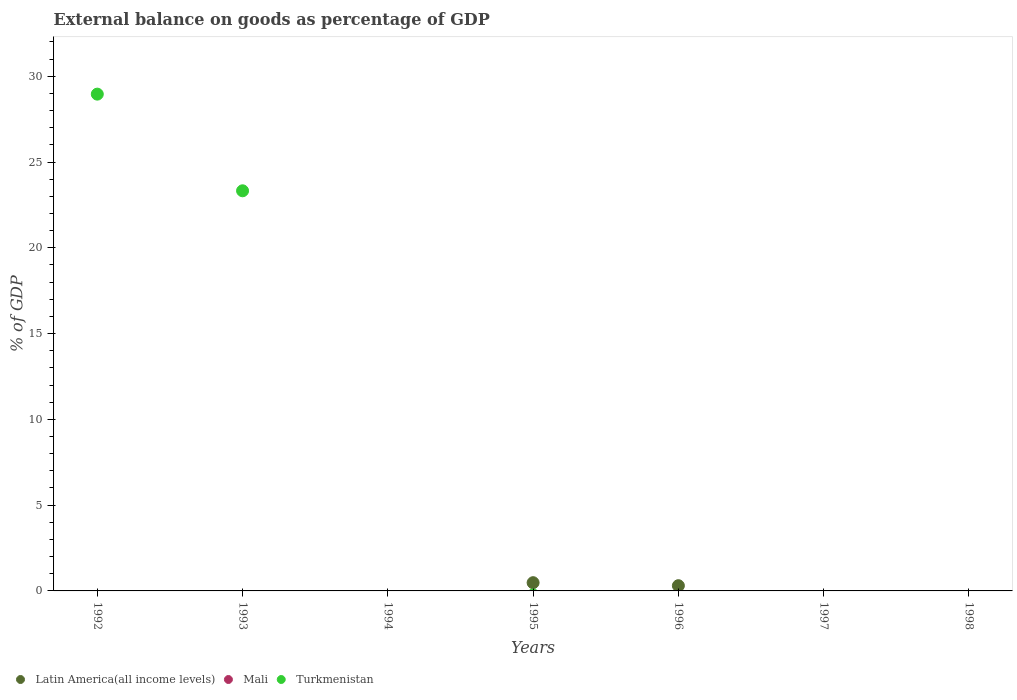What is the external balance on goods as percentage of GDP in Latin America(all income levels) in 1992?
Provide a short and direct response. 0. Across all years, what is the maximum external balance on goods as percentage of GDP in Turkmenistan?
Your answer should be compact. 28.96. Across all years, what is the minimum external balance on goods as percentage of GDP in Mali?
Keep it short and to the point. 0. What is the total external balance on goods as percentage of GDP in Latin America(all income levels) in the graph?
Make the answer very short. 0.79. What is the difference between the external balance on goods as percentage of GDP in Turkmenistan in 1992 and the external balance on goods as percentage of GDP in Latin America(all income levels) in 1994?
Offer a very short reply. 28.96. What is the average external balance on goods as percentage of GDP in Latin America(all income levels) per year?
Provide a short and direct response. 0.11. What is the difference between the highest and the lowest external balance on goods as percentage of GDP in Turkmenistan?
Give a very brief answer. 28.96. In how many years, is the external balance on goods as percentage of GDP in Turkmenistan greater than the average external balance on goods as percentage of GDP in Turkmenistan taken over all years?
Keep it short and to the point. 2. Is it the case that in every year, the sum of the external balance on goods as percentage of GDP in Latin America(all income levels) and external balance on goods as percentage of GDP in Turkmenistan  is greater than the external balance on goods as percentage of GDP in Mali?
Make the answer very short. No. Is the external balance on goods as percentage of GDP in Mali strictly less than the external balance on goods as percentage of GDP in Latin America(all income levels) over the years?
Provide a short and direct response. Yes. How many dotlines are there?
Your response must be concise. 2. How many years are there in the graph?
Offer a very short reply. 7. What is the difference between two consecutive major ticks on the Y-axis?
Your answer should be very brief. 5. Are the values on the major ticks of Y-axis written in scientific E-notation?
Provide a succinct answer. No. Does the graph contain grids?
Offer a very short reply. No. What is the title of the graph?
Your answer should be compact. External balance on goods as percentage of GDP. What is the label or title of the X-axis?
Provide a short and direct response. Years. What is the label or title of the Y-axis?
Your answer should be very brief. % of GDP. What is the % of GDP of Latin America(all income levels) in 1992?
Ensure brevity in your answer.  0. What is the % of GDP of Turkmenistan in 1992?
Provide a short and direct response. 28.96. What is the % of GDP in Latin America(all income levels) in 1993?
Give a very brief answer. 0. What is the % of GDP in Mali in 1993?
Your answer should be compact. 0. What is the % of GDP of Turkmenistan in 1993?
Your response must be concise. 23.32. What is the % of GDP in Mali in 1994?
Your answer should be compact. 0. What is the % of GDP of Turkmenistan in 1994?
Offer a very short reply. 0. What is the % of GDP in Latin America(all income levels) in 1995?
Keep it short and to the point. 0.48. What is the % of GDP of Turkmenistan in 1995?
Provide a succinct answer. 0. What is the % of GDP of Latin America(all income levels) in 1996?
Provide a succinct answer. 0.3. What is the % of GDP in Turkmenistan in 1996?
Your answer should be very brief. 0. What is the % of GDP of Latin America(all income levels) in 1997?
Provide a short and direct response. 0. What is the % of GDP in Turkmenistan in 1997?
Your answer should be very brief. 0. What is the % of GDP of Turkmenistan in 1998?
Provide a short and direct response. 0. Across all years, what is the maximum % of GDP of Latin America(all income levels)?
Your response must be concise. 0.48. Across all years, what is the maximum % of GDP in Turkmenistan?
Your answer should be very brief. 28.96. Across all years, what is the minimum % of GDP of Latin America(all income levels)?
Provide a short and direct response. 0. What is the total % of GDP in Latin America(all income levels) in the graph?
Your answer should be very brief. 0.79. What is the total % of GDP of Mali in the graph?
Make the answer very short. 0. What is the total % of GDP in Turkmenistan in the graph?
Ensure brevity in your answer.  52.28. What is the difference between the % of GDP in Turkmenistan in 1992 and that in 1993?
Make the answer very short. 5.63. What is the difference between the % of GDP in Latin America(all income levels) in 1995 and that in 1996?
Ensure brevity in your answer.  0.18. What is the average % of GDP of Latin America(all income levels) per year?
Offer a very short reply. 0.11. What is the average % of GDP in Turkmenistan per year?
Keep it short and to the point. 7.47. What is the ratio of the % of GDP in Turkmenistan in 1992 to that in 1993?
Your answer should be very brief. 1.24. What is the ratio of the % of GDP in Latin America(all income levels) in 1995 to that in 1996?
Offer a terse response. 1.57. What is the difference between the highest and the lowest % of GDP in Latin America(all income levels)?
Offer a very short reply. 0.48. What is the difference between the highest and the lowest % of GDP in Turkmenistan?
Your response must be concise. 28.96. 